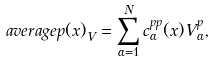Convert formula to latex. <formula><loc_0><loc_0><loc_500><loc_500>\ a v e r a g e { p ( x ) } _ { V } = \sum _ { \alpha = 1 } ^ { N } c ^ { p p } _ { \alpha } ( x ) V ^ { p } _ { \alpha } ,</formula> 